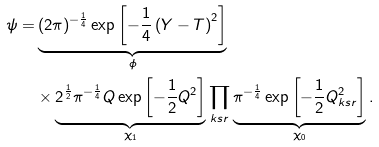<formula> <loc_0><loc_0><loc_500><loc_500>\psi = & \underbrace { ( 2 \pi ) ^ { - \frac { 1 } { 4 } } \exp \left [ - \frac { 1 } { 4 } \left ( Y - T \right ) ^ { 2 } \right ] } _ { \phi } \\ & \times \underbrace { 2 ^ { \frac { 1 } { 2 } } \pi ^ { - \frac { 1 } { 4 } } Q \exp \left [ - \frac { 1 } { 2 } Q ^ { 2 } \right ] } _ { \chi _ { 1 } } \prod _ { k s r } \underbrace { \pi ^ { - \frac { 1 } { 4 } } \exp \left [ - \frac { 1 } { 2 } Q _ { k s r } ^ { 2 } \right ] } _ { \chi _ { 0 } } .</formula> 